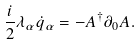<formula> <loc_0><loc_0><loc_500><loc_500>\frac { i } { 2 } \lambda _ { \alpha } \dot { q } _ { \alpha } = - A ^ { \dagger } \partial _ { 0 } A .</formula> 